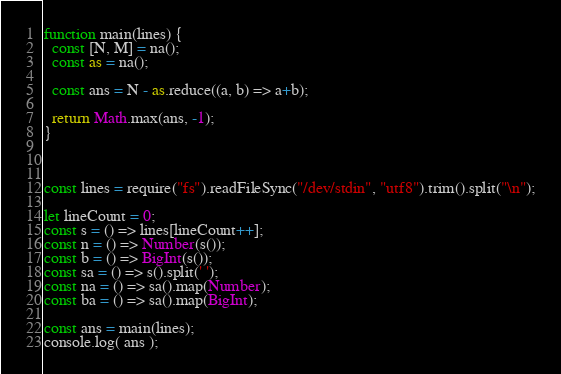<code> <loc_0><loc_0><loc_500><loc_500><_JavaScript_>function main(lines) {
  const [N, M] = na();
  const as = na();

  const ans = N - as.reduce((a, b) => a+b);
  
  return Math.max(ans, -1);
}



const lines = require("fs").readFileSync("/dev/stdin", "utf8").trim().split("\n");

let lineCount = 0;
const s = () => lines[lineCount++];
const n = () => Number(s());
const b = () => BigInt(s());
const sa = () => s().split(' ');
const na = () => sa().map(Number);
const ba = () => sa().map(BigInt);

const ans = main(lines);
console.log( ans );</code> 